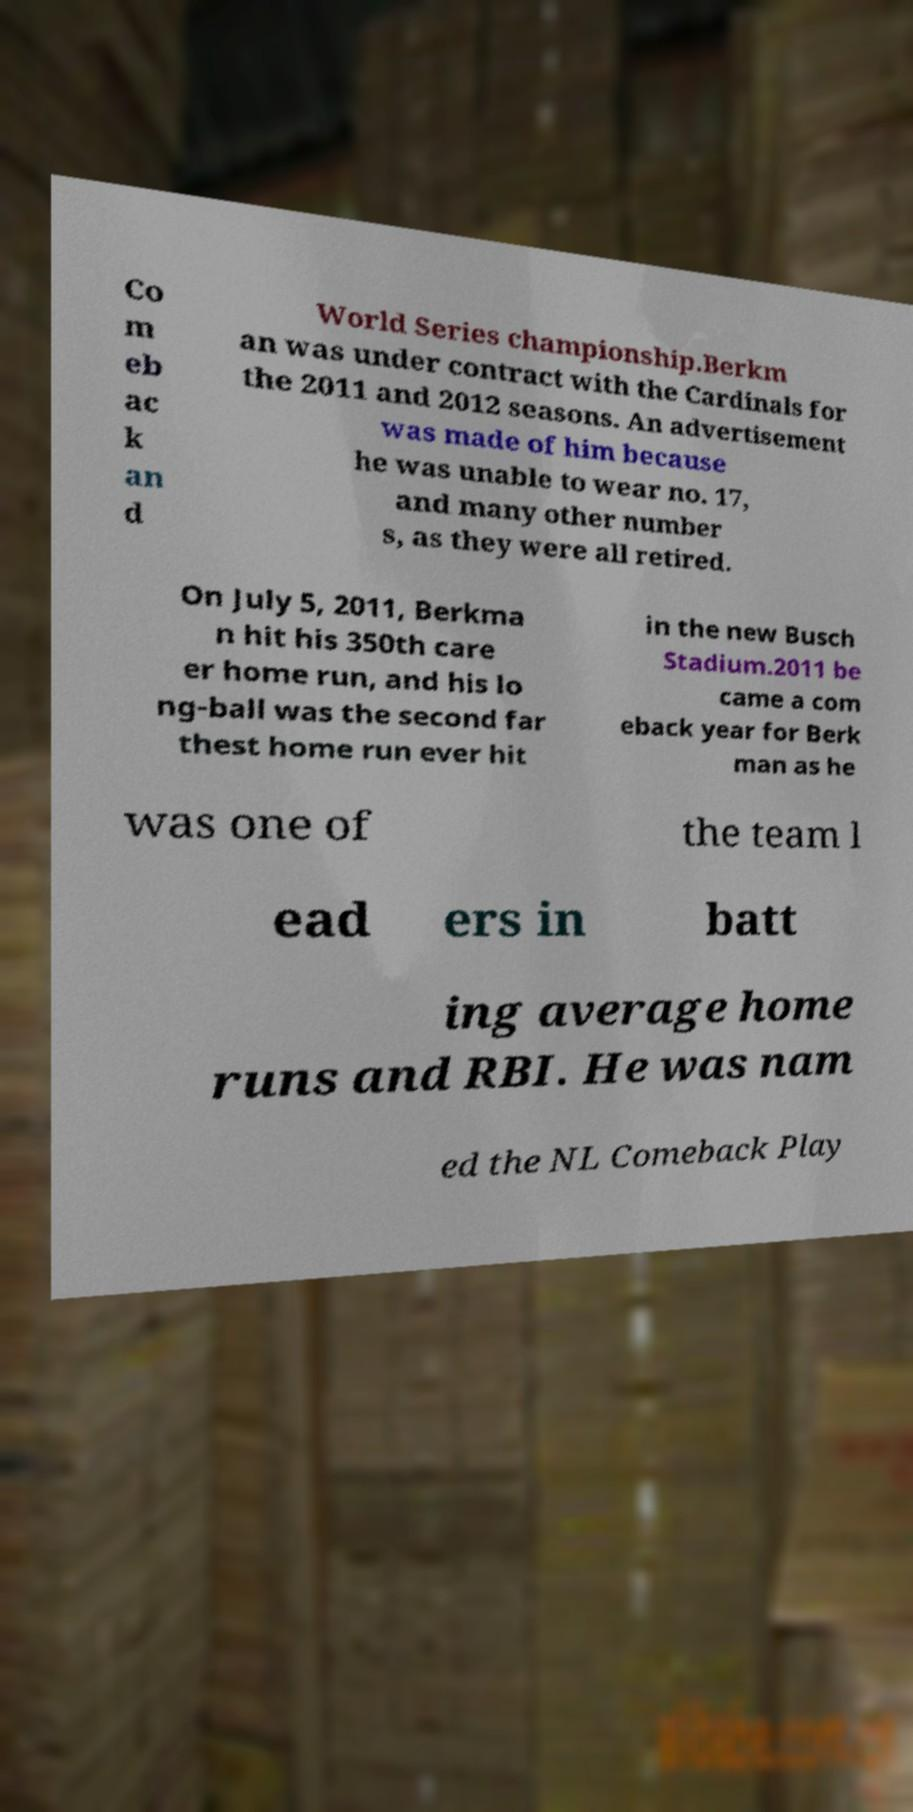Can you read and provide the text displayed in the image?This photo seems to have some interesting text. Can you extract and type it out for me? Co m eb ac k an d World Series championship.Berkm an was under contract with the Cardinals for the 2011 and 2012 seasons. An advertisement was made of him because he was unable to wear no. 17, and many other number s, as they were all retired. On July 5, 2011, Berkma n hit his 350th care er home run, and his lo ng-ball was the second far thest home run ever hit in the new Busch Stadium.2011 be came a com eback year for Berk man as he was one of the team l ead ers in batt ing average home runs and RBI. He was nam ed the NL Comeback Play 